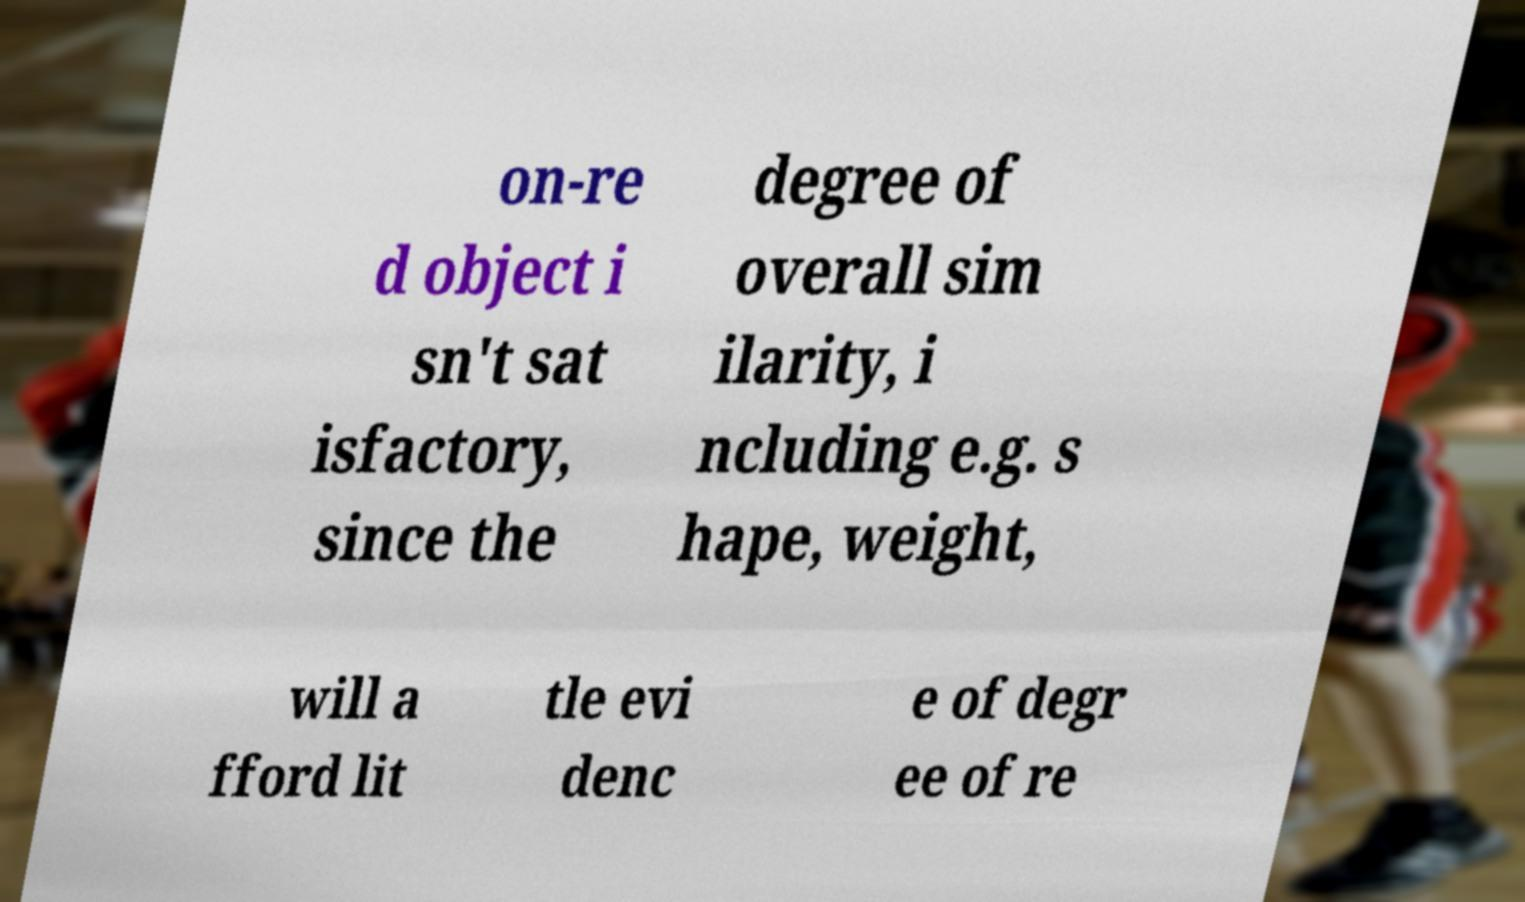There's text embedded in this image that I need extracted. Can you transcribe it verbatim? on-re d object i sn't sat isfactory, since the degree of overall sim ilarity, i ncluding e.g. s hape, weight, will a fford lit tle evi denc e of degr ee of re 